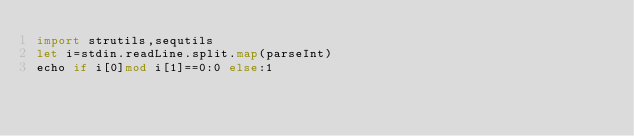Convert code to text. <code><loc_0><loc_0><loc_500><loc_500><_Nim_>import strutils,sequtils
let i=stdin.readLine.split.map(parseInt)
echo if i[0]mod i[1]==0:0 else:1</code> 